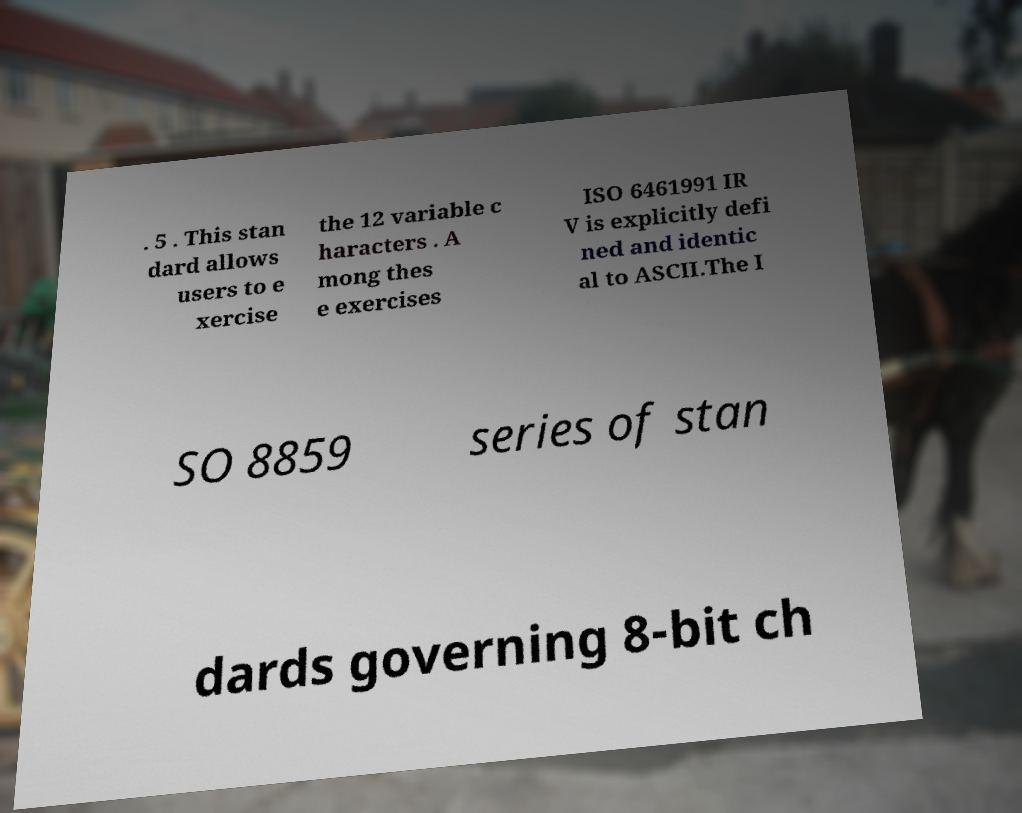Could you assist in decoding the text presented in this image and type it out clearly? . 5 . This stan dard allows users to e xercise the 12 variable c haracters . A mong thes e exercises ISO 6461991 IR V is explicitly defi ned and identic al to ASCII.The I SO 8859 series of stan dards governing 8-bit ch 